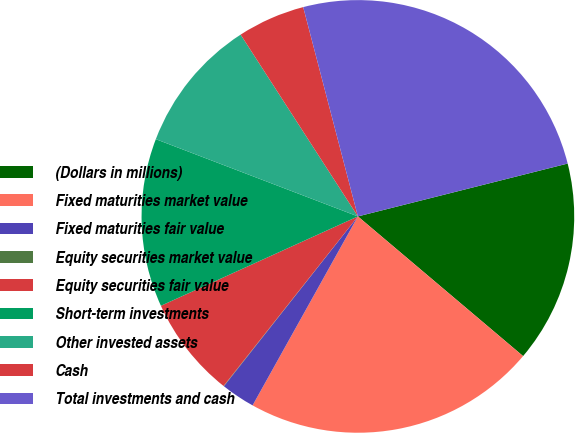Convert chart. <chart><loc_0><loc_0><loc_500><loc_500><pie_chart><fcel>(Dollars in millions)<fcel>Fixed maturities market value<fcel>Fixed maturities fair value<fcel>Equity securities market value<fcel>Equity securities fair value<fcel>Short-term investments<fcel>Other invested assets<fcel>Cash<fcel>Total investments and cash<nl><fcel>15.1%<fcel>21.92%<fcel>2.54%<fcel>0.03%<fcel>7.56%<fcel>12.59%<fcel>10.07%<fcel>5.05%<fcel>25.14%<nl></chart> 